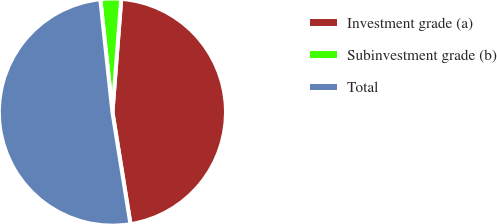<chart> <loc_0><loc_0><loc_500><loc_500><pie_chart><fcel>Investment grade (a)<fcel>Subinvestment grade (b)<fcel>Total<nl><fcel>46.22%<fcel>2.94%<fcel>50.84%<nl></chart> 